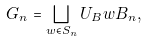Convert formula to latex. <formula><loc_0><loc_0><loc_500><loc_500>G _ { n } = \bigsqcup _ { w \in S _ { n } } U _ { B } w B _ { n } ,</formula> 